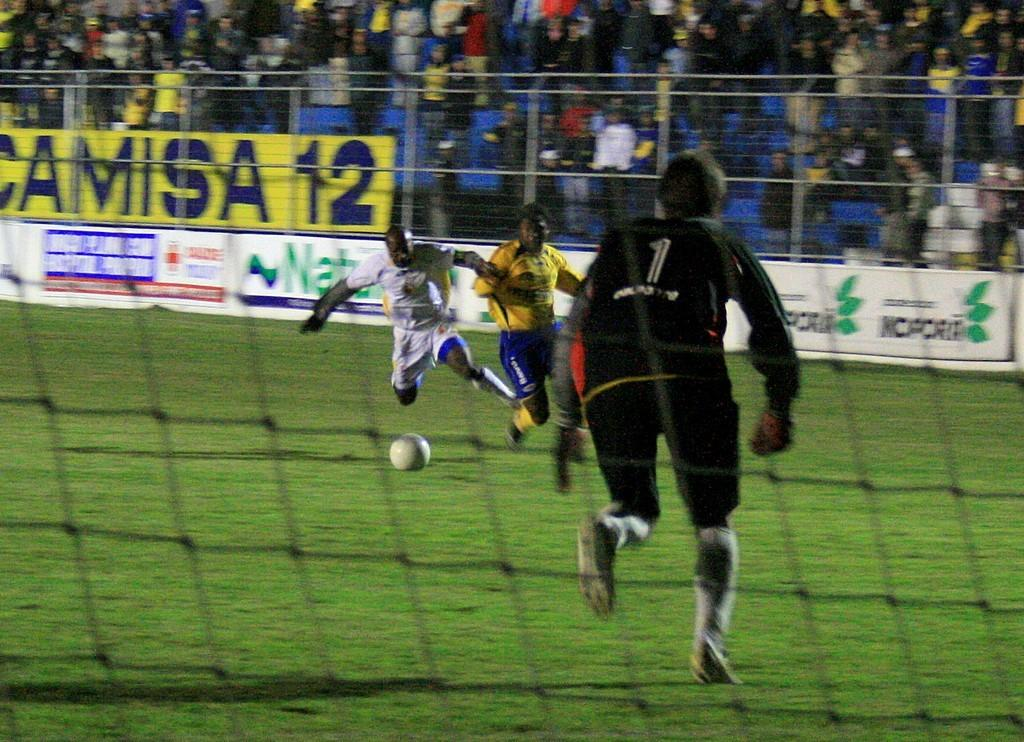<image>
Offer a succinct explanation of the picture presented. The goalkeeper wearing number 1 looks on as two players fight for the soccer ball. 